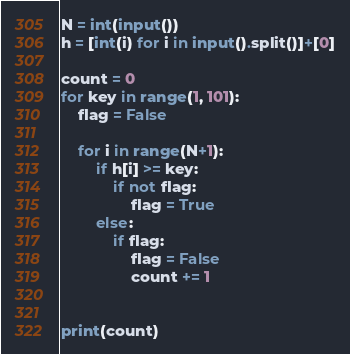Convert code to text. <code><loc_0><loc_0><loc_500><loc_500><_Python_>N = int(input())
h = [int(i) for i in input().split()]+[0]

count = 0
for key in range(1, 101):
    flag = False

    for i in range(N+1):
        if h[i] >= key:
            if not flag:
                flag = True
        else:
            if flag:
                flag = False
                count += 1


print(count)</code> 